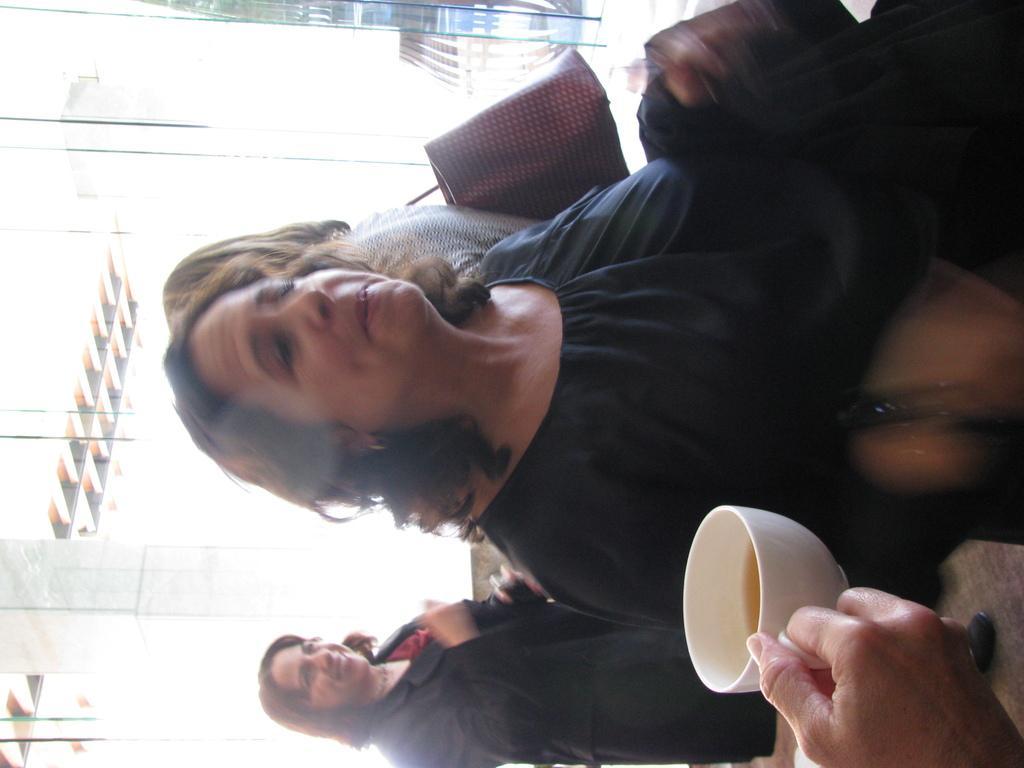Can you describe this image briefly? In the picture I can see a woman and she is wearing a black color top. I can see a woman at the bottom of the picture and she is smiling. There is another woman and she is carrying a bag. I can see the hands of a person holding the cup. 